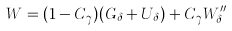Convert formula to latex. <formula><loc_0><loc_0><loc_500><loc_500>W = ( 1 - C _ { \gamma } ) ( G _ { \delta } + U _ { \delta } ) + C _ { \gamma } W _ { \delta } ^ { \prime \prime }</formula> 